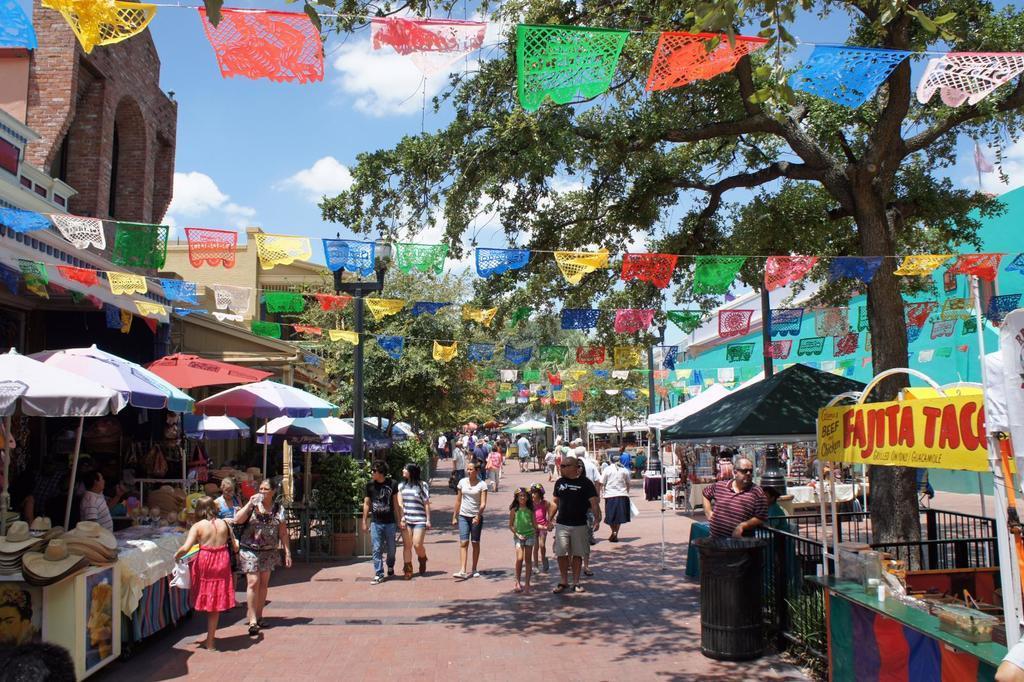In one or two sentences, can you explain what this image depicts? In this image we can see stalls. There are people walking on the road. There are light poles. There are trees, flags. At the top of the image there is sky and clouds. 